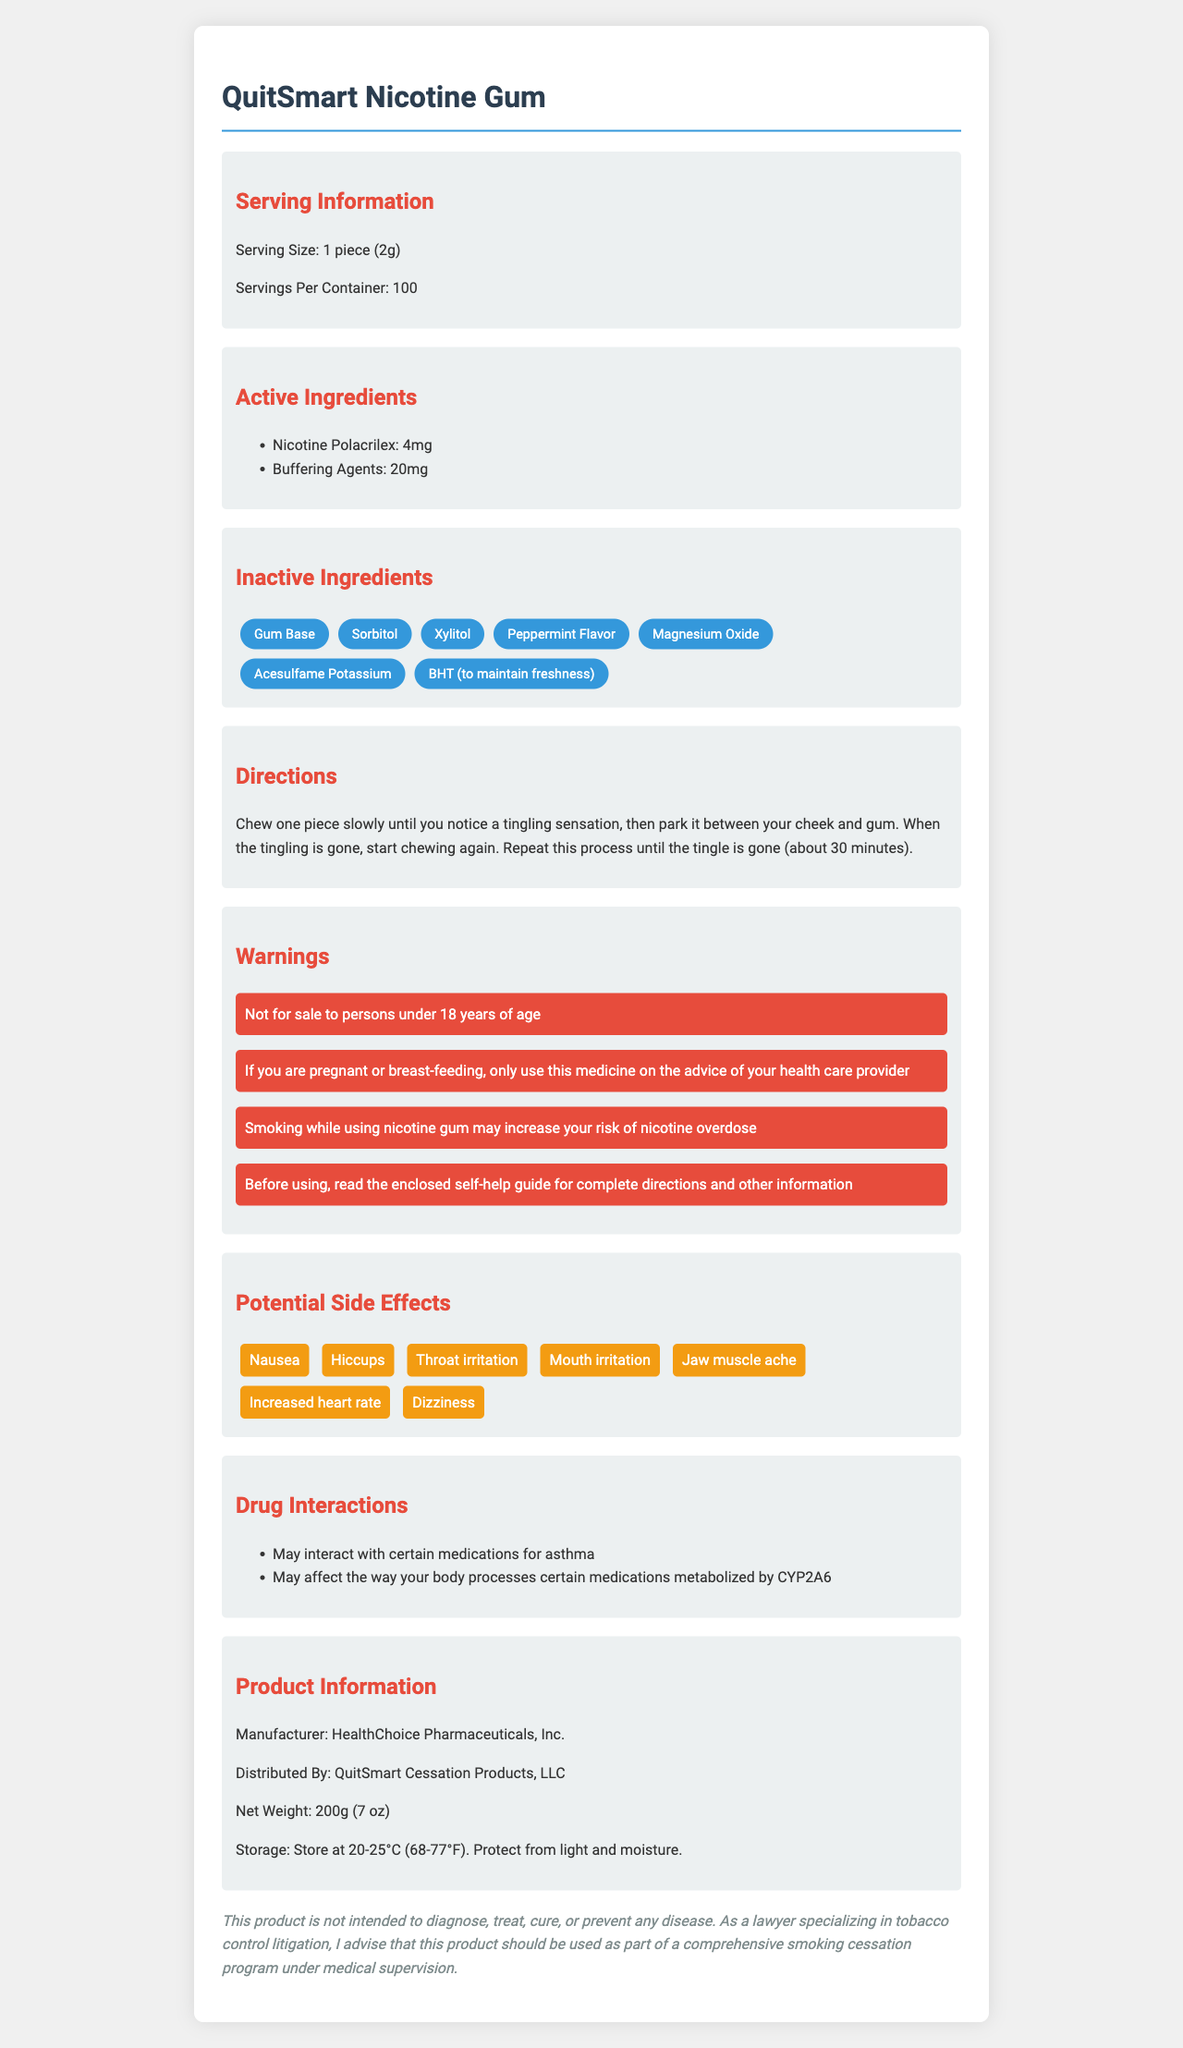who is the manufacturer of QuitSmart Nicotine Gum? The document lists the manufacturer in the "Product Information" section as HealthChoice Pharmaceuticals, Inc.
Answer: HealthChoice Pharmaceuticals, Inc. what is the active ingredient and its dosage in each piece of gum? The "Active Ingredients" section specifies that each piece contains 4mg of Nicotine Polacrilex.
Answer: Nicotine Polacrilex, 4mg how should QuitSmart Nicotine Gum be stored? The "Product Information" section includes storage instructions, stating to store it at 20-25°C and protect it from light and moisture.
Answer: Store at 20-25°C (68-77°F). Protect from light and moisture. what are the potential side effects of QuitSmart Nicotine Gum? The "Potential Side Effects" section lists these specific side effects.
Answer: Nausea, Hiccups, Throat irritation, Mouth irritation, Jaw muscle ache, Increased heart rate, Dizziness who is the product distributed by? The "Product Information" section mentions that the product is distributed by QuitSmart Cessation Products, LLC.
Answer: QuitSmart Cessation Products, LLC what are the warnings associated with using QuitSmart Nicotine Gum? The "Warnings" section lists these specific warnings for the product.
Answer: Not for sale to persons under 18 years of age; If you are pregnant or breast-feeding, only use this medicine on the advice of your health care provider; Smoking while using nicotine gum may increase your risk of nicotine overdose; Before using, read the enclosed self-help guide for complete directions and other information which of the following is not an inactive ingredient in QuitSmart Nicotine Gum? A. Sorbitol B. Xylitol C. Ascorbic acid D. Peppermint Flavor The document's "Inactive Ingredients" section lists Sorbitol, Xylitol, and Peppermint Flavor, but does not list Ascorbic acid.
Answer: C what is the recommended usage direction for QuitSmart Nicotine Gum? The "Directions" section provides these specific instructions for using the gum.
Answer: Chew one piece slowly until you notice a tingling sensation, then park it between your cheek and gum. When the tingling is gone, start chewing again. Repeat this process until the tingle is gone (about 30 minutes). what is the net weight of the QuitSmart Nicotine Gum container? A. 150g B. 200g C. 250g D. 300g The "Product Information" section states that the net weight is 200g (7 oz).
Answer: B is QuitSmart Nicotine Gum safe to use during pregnancy without consulting a health care provider? The "Warnings" section states that if you are pregnant or breast-feeding, only use this medicine on the advice of your health care provider.
Answer: No describe the entire document. The document gives a comprehensive overview of QuitSmart Nicotine Gum, covering all necessary details for a consumer to understand the product, how to use it, and the risks associated with it.
Answer: The document provides detailed information about QuitSmart Nicotine Gum, including serving size, number of servings, active and inactive ingredients, usage instructions, warnings, potential side effects, drug interactions, and product information such as manufacturer, distributor, net weight, and storage instructions. It also includes a legal disclaimer. does this product cure smoking addiction? The "Legal Disclaimer" in the document specifically states that this product is not intended to diagnose, treat, cure, or prevent any disease.
Answer: Cannot be determined 